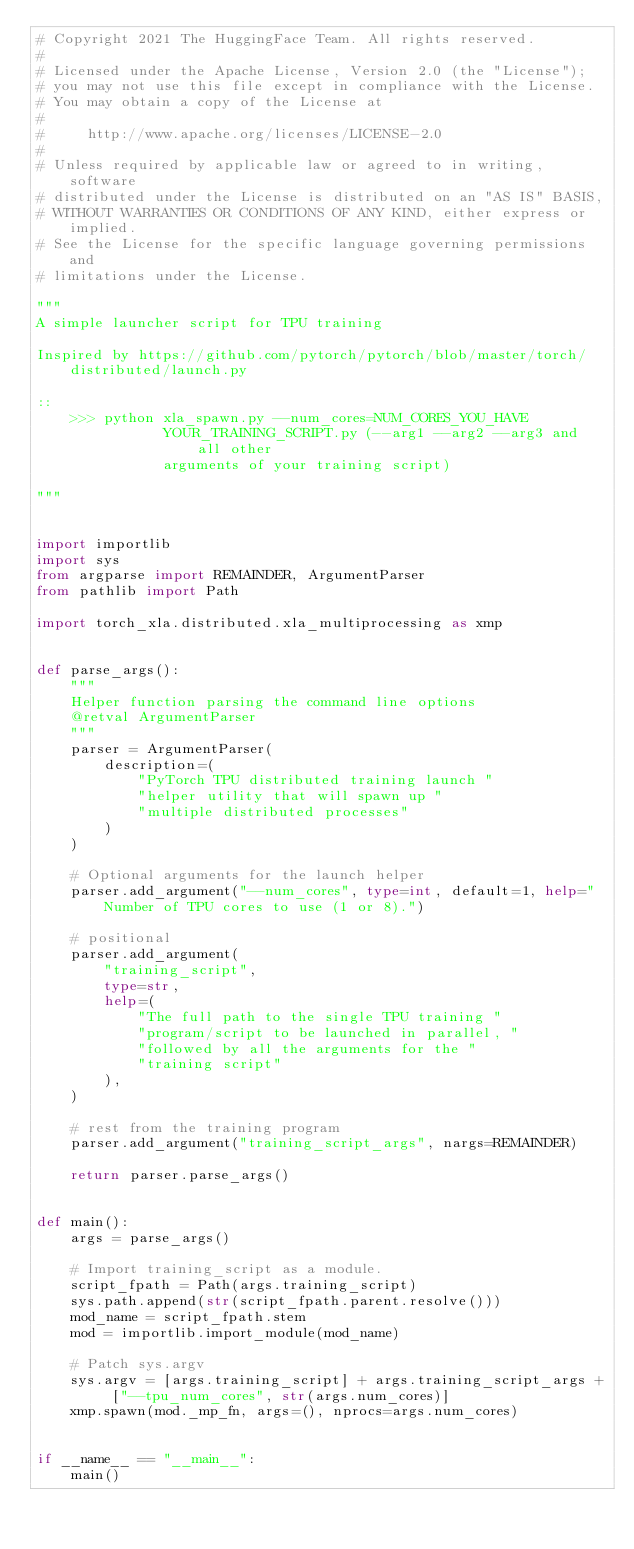<code> <loc_0><loc_0><loc_500><loc_500><_Python_># Copyright 2021 The HuggingFace Team. All rights reserved.
#
# Licensed under the Apache License, Version 2.0 (the "License");
# you may not use this file except in compliance with the License.
# You may obtain a copy of the License at
#
#     http://www.apache.org/licenses/LICENSE-2.0
#
# Unless required by applicable law or agreed to in writing, software
# distributed under the License is distributed on an "AS IS" BASIS,
# WITHOUT WARRANTIES OR CONDITIONS OF ANY KIND, either express or implied.
# See the License for the specific language governing permissions and
# limitations under the License.

"""
A simple launcher script for TPU training

Inspired by https://github.com/pytorch/pytorch/blob/master/torch/distributed/launch.py

::
    >>> python xla_spawn.py --num_cores=NUM_CORES_YOU_HAVE
               YOUR_TRAINING_SCRIPT.py (--arg1 --arg2 --arg3 and all other
               arguments of your training script)

"""


import importlib
import sys
from argparse import REMAINDER, ArgumentParser
from pathlib import Path

import torch_xla.distributed.xla_multiprocessing as xmp


def parse_args():
    """
    Helper function parsing the command line options
    @retval ArgumentParser
    """
    parser = ArgumentParser(
        description=(
            "PyTorch TPU distributed training launch "
            "helper utility that will spawn up "
            "multiple distributed processes"
        )
    )

    # Optional arguments for the launch helper
    parser.add_argument("--num_cores", type=int, default=1, help="Number of TPU cores to use (1 or 8).")

    # positional
    parser.add_argument(
        "training_script",
        type=str,
        help=(
            "The full path to the single TPU training "
            "program/script to be launched in parallel, "
            "followed by all the arguments for the "
            "training script"
        ),
    )

    # rest from the training program
    parser.add_argument("training_script_args", nargs=REMAINDER)

    return parser.parse_args()


def main():
    args = parse_args()

    # Import training_script as a module.
    script_fpath = Path(args.training_script)
    sys.path.append(str(script_fpath.parent.resolve()))
    mod_name = script_fpath.stem
    mod = importlib.import_module(mod_name)

    # Patch sys.argv
    sys.argv = [args.training_script] + args.training_script_args + ["--tpu_num_cores", str(args.num_cores)]
    xmp.spawn(mod._mp_fn, args=(), nprocs=args.num_cores)


if __name__ == "__main__":
    main()
</code> 